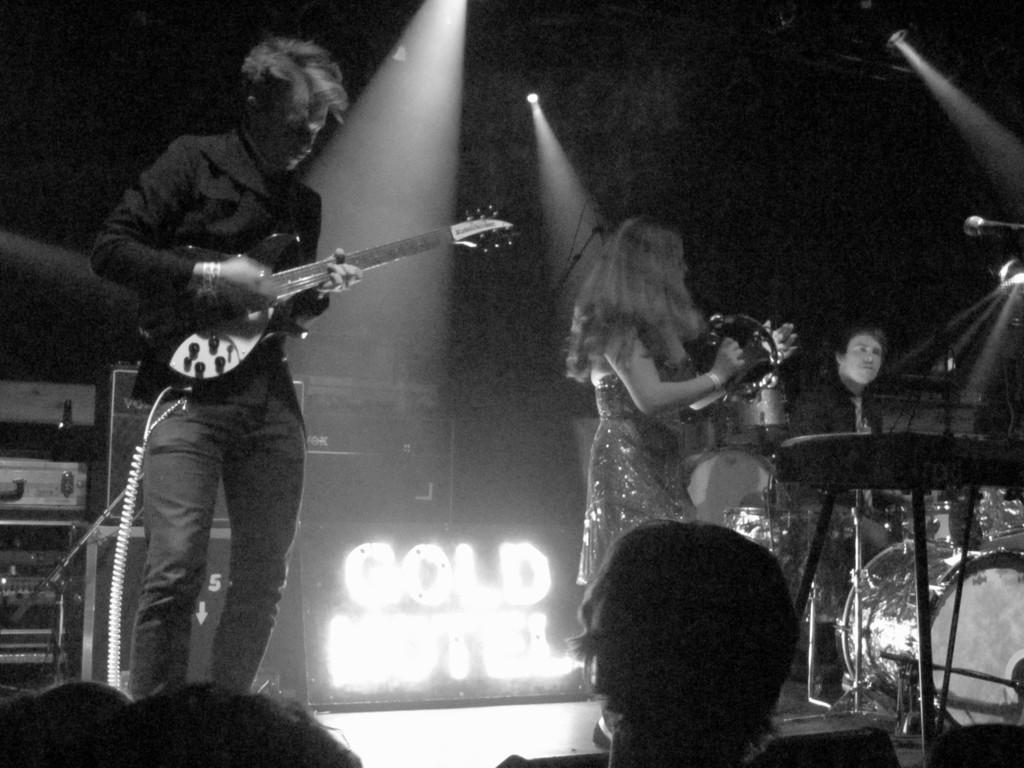What is the color scheme of the image? The image is black and white. How many people are in the image? There are two persons in the image. Where are the persons located in the image? The persons are standing on a stage. What are the persons doing in the image? The persons are playing musical instruments. What can be seen in the image that might be used for lighting purposes? There are focusing lights visible in the image. What type of fowl can be seen playing the guitar in the image? There is no fowl or guitar present in the image. In which direction are the persons facing in the image? The provided facts do not specify the direction the persons are facing in the image. 